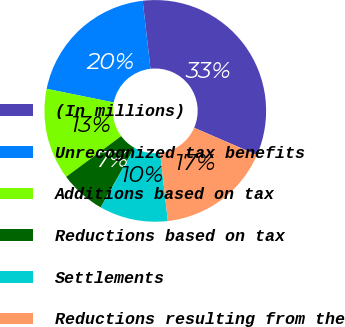<chart> <loc_0><loc_0><loc_500><loc_500><pie_chart><fcel>(In millions)<fcel>Unrecognized tax benefits<fcel>Additions based on tax<fcel>Reductions based on tax<fcel>Settlements<fcel>Reductions resulting from the<nl><fcel>33.33%<fcel>20.0%<fcel>13.33%<fcel>6.67%<fcel>10.0%<fcel>16.67%<nl></chart> 